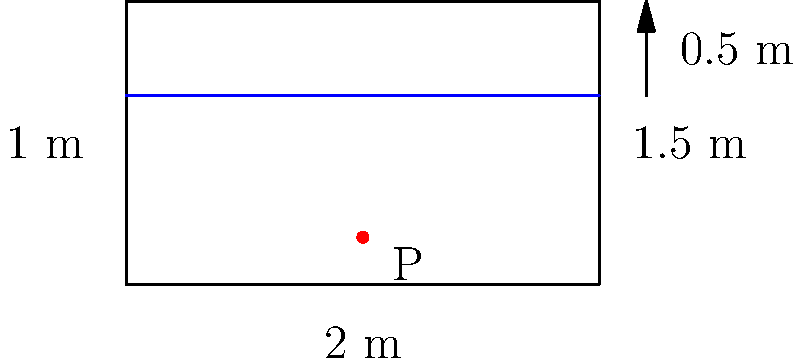As you prepare for a baptism service, you notice the baptismal font in your church. It measures 2 m long, 1.5 m wide, and 1 m deep. The font is filled with water to a depth of 0.5 m. What is the water pressure at a point 0.5 m from the bottom of the font? To calculate the water pressure at a point in a static fluid, we can use the hydrostatic pressure equation:

$$P = \rho \cdot g \cdot h$$

Where:
- $P$ is the pressure (in Pa or N/m²)
- $\rho$ (rho) is the density of water (1000 kg/m³)
- $g$ is the acceleration due to gravity (9.81 m/s²)
- $h$ is the height of the water column above the point (in m)

Steps:
1. Identify the height of the water column above the point:
   The total depth of water is 0.5 m, and the point is 0.5 m from the bottom.
   So, $h = 0.5 \text{ m} - 0.5 \text{ m} = 0 \text{ m}$

2. Substitute the values into the equation:
   $$P = 1000 \text{ kg/m³} \cdot 9.81 \text{ m/s²} \cdot 0 \text{ m}$$

3. Calculate the pressure:
   $$P = 0 \text{ Pa} = 0 \text{ N/m²}$$

The pressure at the point is 0 Pa because it's at the same level as the water surface. There's no water column above it exerting pressure.
Answer: 0 Pa 